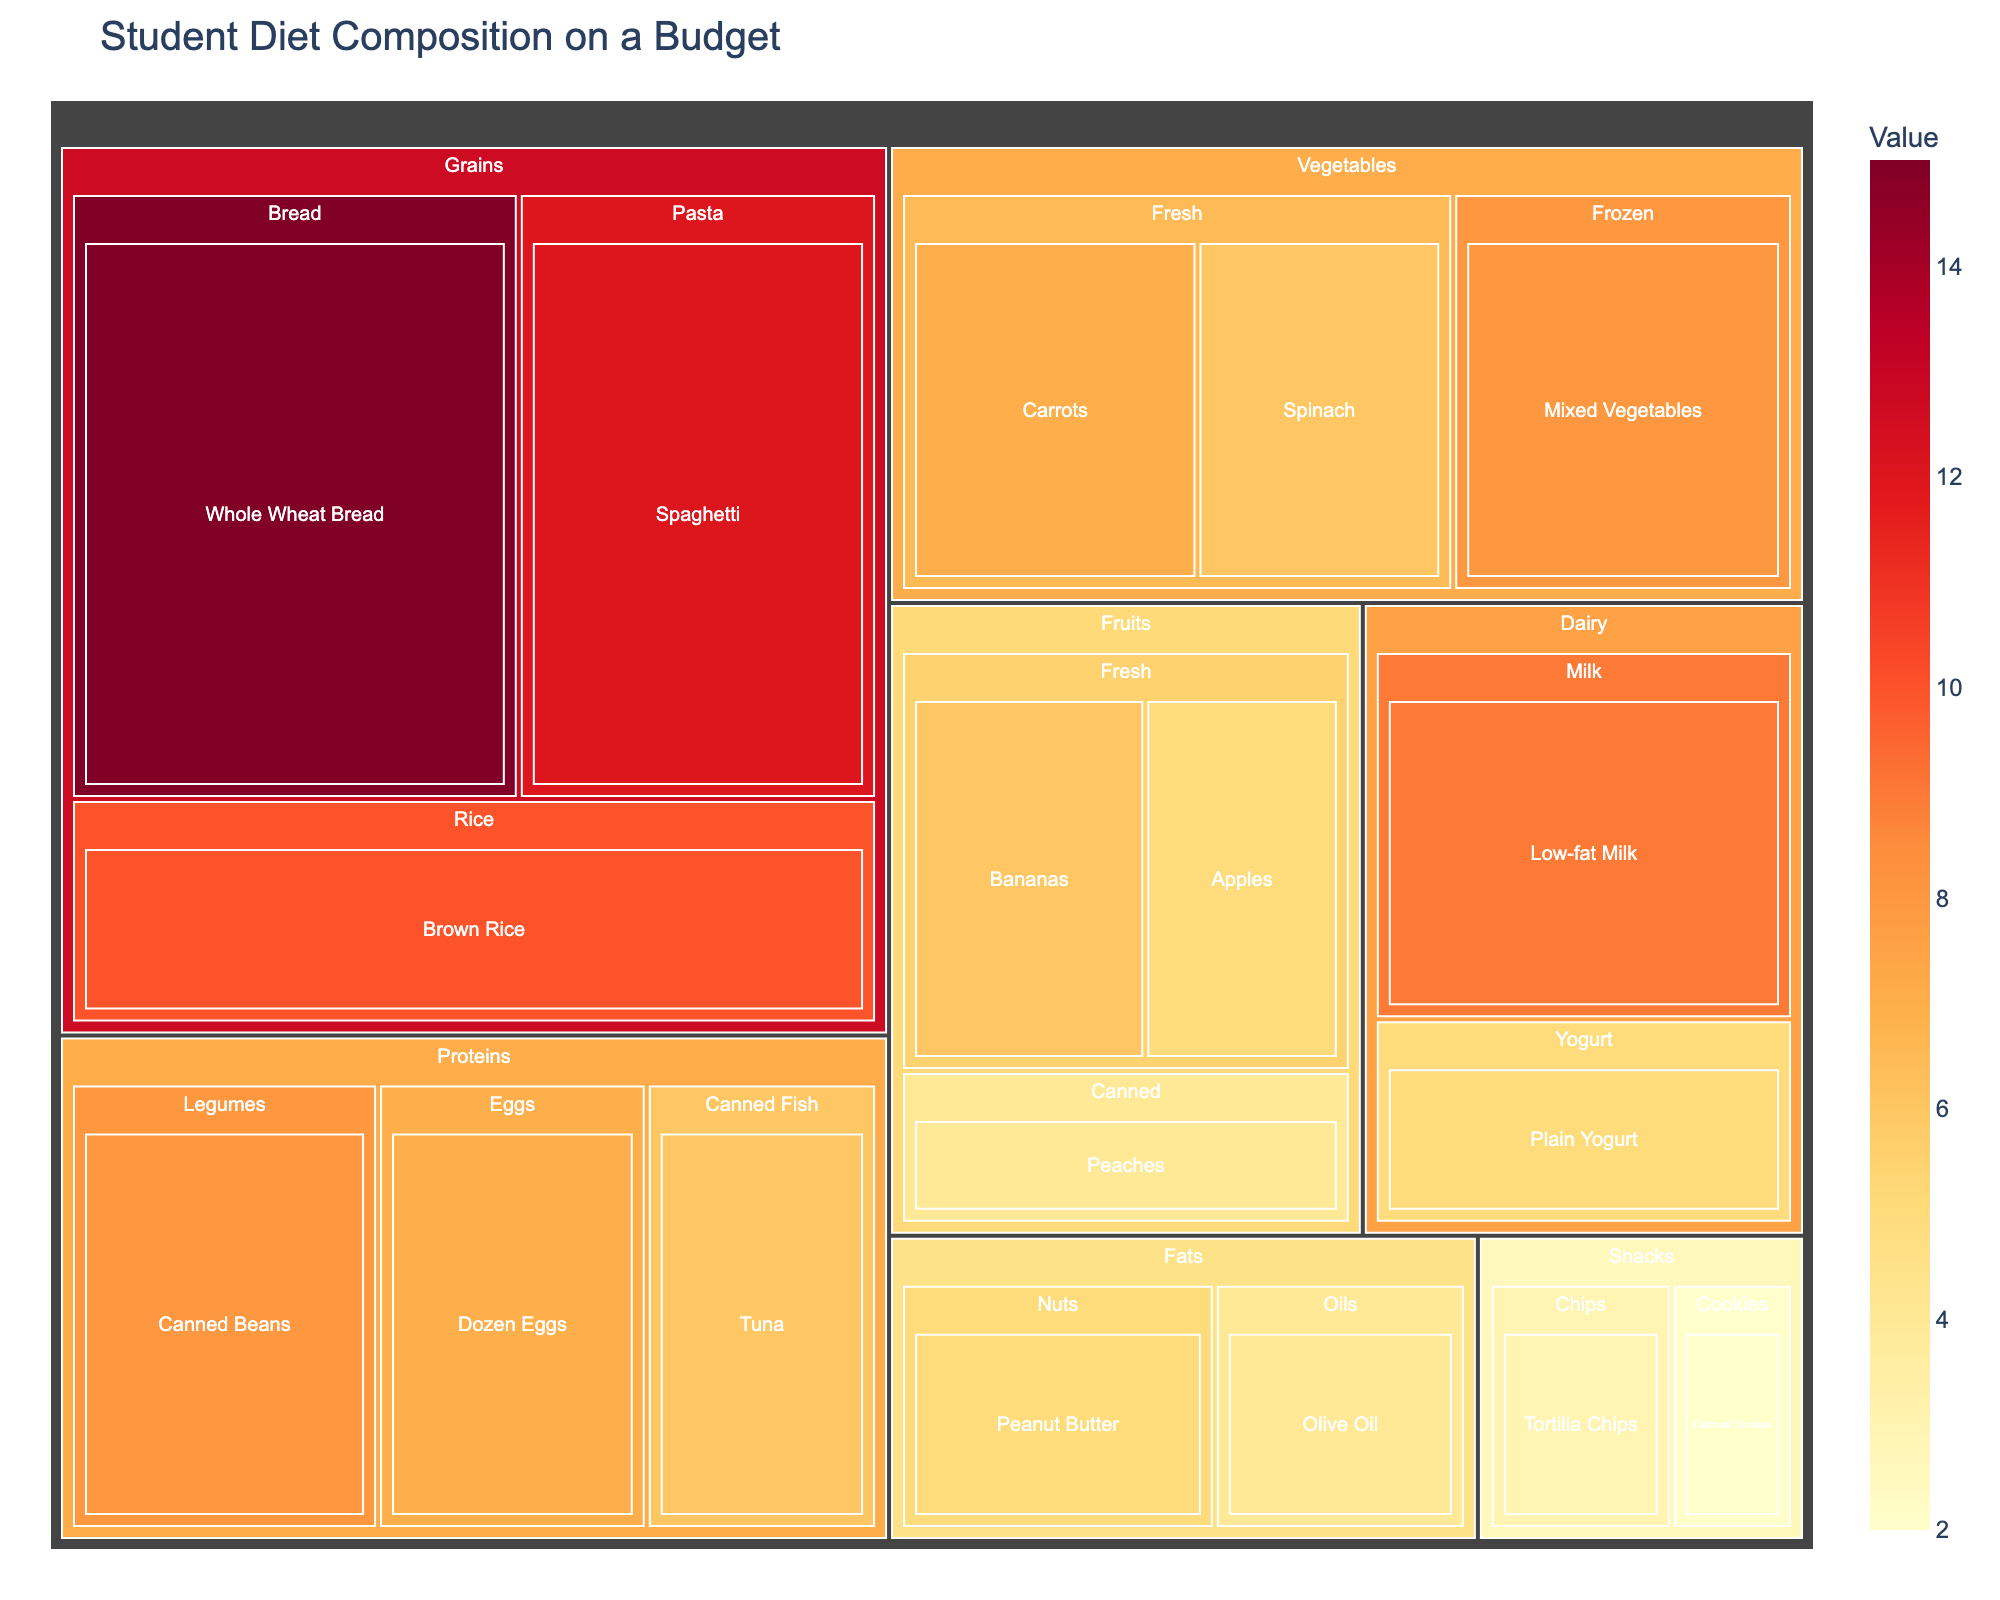What's the title of the figure? The title is typically placed at the top of the figure and is straightforward to locate. The title given in the plot is "Student Diet Composition on a Budget".
Answer: Student Diet Composition on a Budget How many food groups are shown in the treemap? The food groups in a treemap are typically hierarchical clusters. On close inspection, the categories are Grains, Proteins, Dairy, Fruits, Vegetables, Fats, and Snacks. Counting these gives the number of groups.
Answer: 7 Which food group has the most items and how many? By looking at the treemap, count the number of items within each food group rectangle. The Grains group has the most, with three items (Whole Wheat Bread, Spaghetti, Brown Rice).
Answer: Grains, 3 What is the sum of values for all items in the Dairy category? Identify the items in the Dairy group (Low-fat Milk, Plain Yogurt), then sum their values (9 for Milk + 5 for Yogurt). The total is 9 + 5 = 14.
Answer: 14 Which item has the highest value and what is that value? The value is represented by the size and color intensity in the treemap. The item Whole Wheat Bread in the Grains group has the highest value, which is 15.
Answer: Whole Wheat Bread, 15 What is the total value of the Fruits food group? Identify all items in the Fruits group (Bananas, Apples, Peaches), then sum their values (6 for Bananas + 5 for Apples + 4 for Peaches). The total is 6 + 5 + 4 = 15.
Answer: 15 How does the value of Mixed Vegetables compare to Canned Beans? Find the values for Mixed Vegetables in the Vegetables group (8) and Canned Beans in the Proteins group (8). Comparing these shows that Mixed Vegetables have the same value as Canned Beans.
Answer: Same, 8 Are the values of Peanut Butter and Tuna the same? Locate the values for Peanut Butter in the Fats group (5) and Tuna in the Proteins group (6). From this, we can see they have different values.
Answer: No Which has a higher value: Fresh Carrots or Spinach? Fresh Carrots in the Vegetables group have a value of 7, while Spinach also in the Vegetables group has a value of 6. Therefore, Fresh Carrots have a higher value.
Answer: Fresh Carrots What's the difference in value between Tortilla Chips and Oatmeal Cookies? Find the values of Tortilla Chips in the Snacks group (3) and Oatmeal Cookies in the Snacks group (2). The difference is 3 - 2 = 1.
Answer: 1 